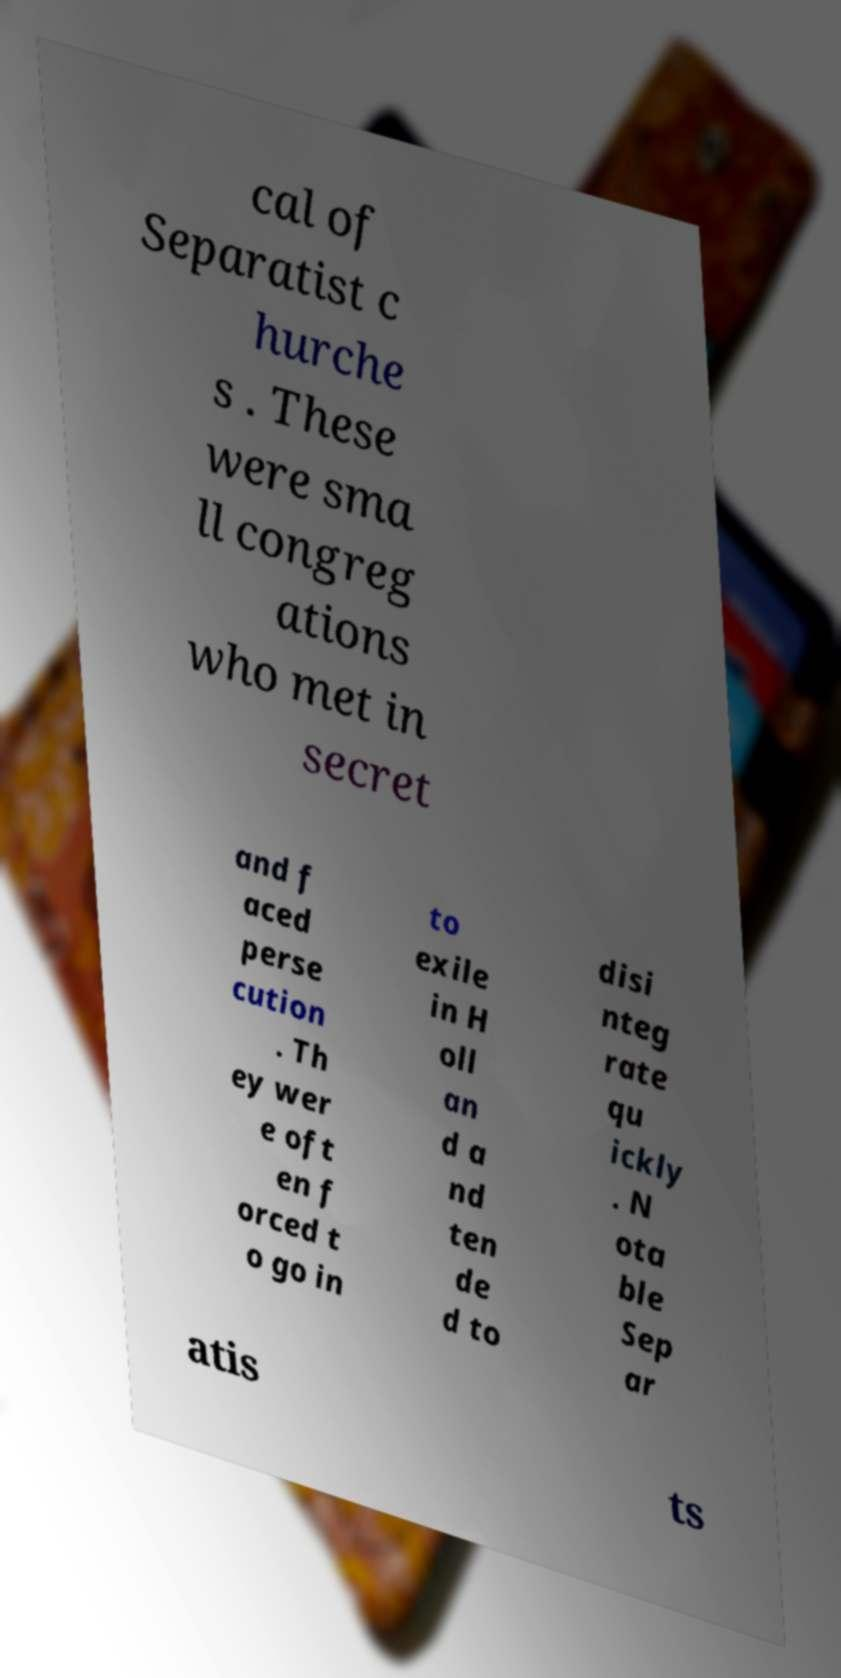Can you read and provide the text displayed in the image?This photo seems to have some interesting text. Can you extract and type it out for me? cal of Separatist c hurche s . These were sma ll congreg ations who met in secret and f aced perse cution . Th ey wer e oft en f orced t o go in to exile in H oll an d a nd ten de d to disi nteg rate qu ickly . N ota ble Sep ar atis ts 